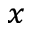<formula> <loc_0><loc_0><loc_500><loc_500>_ { x }</formula> 